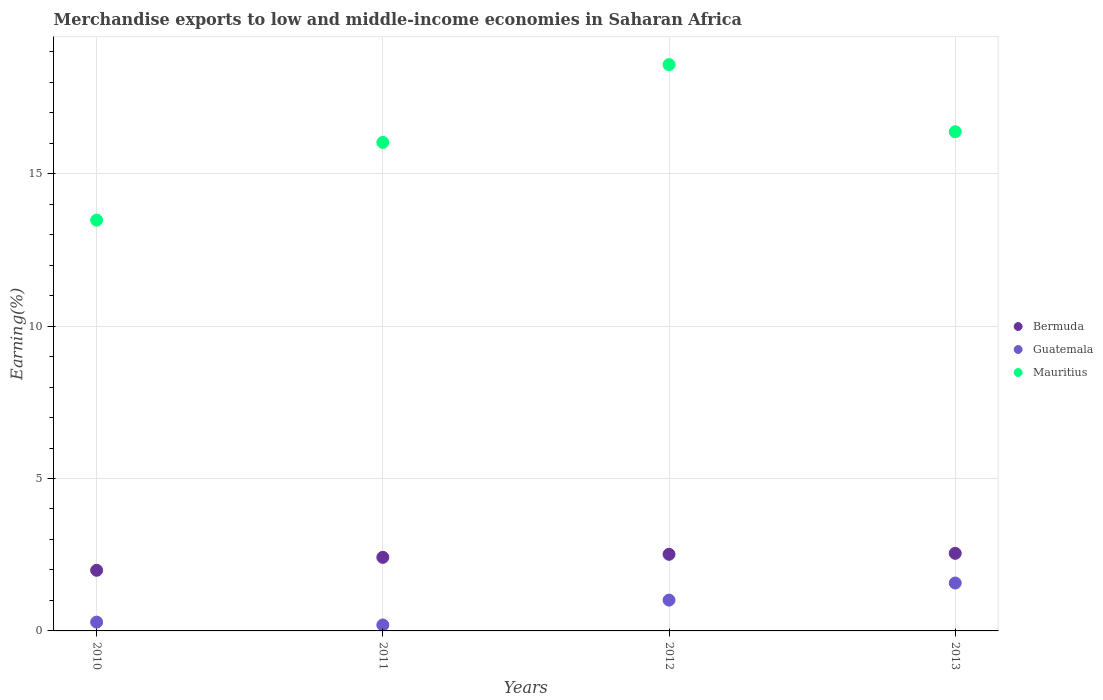How many different coloured dotlines are there?
Provide a short and direct response. 3. What is the percentage of amount earned from merchandise exports in Mauritius in 2010?
Your answer should be very brief. 13.48. Across all years, what is the maximum percentage of amount earned from merchandise exports in Guatemala?
Give a very brief answer. 1.57. Across all years, what is the minimum percentage of amount earned from merchandise exports in Bermuda?
Offer a terse response. 1.99. In which year was the percentage of amount earned from merchandise exports in Guatemala maximum?
Your answer should be very brief. 2013. What is the total percentage of amount earned from merchandise exports in Bermuda in the graph?
Offer a very short reply. 9.46. What is the difference between the percentage of amount earned from merchandise exports in Bermuda in 2011 and that in 2013?
Offer a terse response. -0.13. What is the difference between the percentage of amount earned from merchandise exports in Guatemala in 2011 and the percentage of amount earned from merchandise exports in Bermuda in 2010?
Provide a short and direct response. -1.79. What is the average percentage of amount earned from merchandise exports in Mauritius per year?
Ensure brevity in your answer.  16.11. In the year 2012, what is the difference between the percentage of amount earned from merchandise exports in Bermuda and percentage of amount earned from merchandise exports in Guatemala?
Give a very brief answer. 1.5. In how many years, is the percentage of amount earned from merchandise exports in Mauritius greater than 14 %?
Ensure brevity in your answer.  3. What is the ratio of the percentage of amount earned from merchandise exports in Guatemala in 2011 to that in 2013?
Your answer should be compact. 0.12. Is the percentage of amount earned from merchandise exports in Bermuda in 2010 less than that in 2011?
Your answer should be compact. Yes. Is the difference between the percentage of amount earned from merchandise exports in Bermuda in 2011 and 2012 greater than the difference between the percentage of amount earned from merchandise exports in Guatemala in 2011 and 2012?
Keep it short and to the point. Yes. What is the difference between the highest and the second highest percentage of amount earned from merchandise exports in Mauritius?
Provide a succinct answer. 2.2. What is the difference between the highest and the lowest percentage of amount earned from merchandise exports in Guatemala?
Your answer should be compact. 1.38. In how many years, is the percentage of amount earned from merchandise exports in Bermuda greater than the average percentage of amount earned from merchandise exports in Bermuda taken over all years?
Keep it short and to the point. 3. Is it the case that in every year, the sum of the percentage of amount earned from merchandise exports in Guatemala and percentage of amount earned from merchandise exports in Mauritius  is greater than the percentage of amount earned from merchandise exports in Bermuda?
Offer a very short reply. Yes. Is the percentage of amount earned from merchandise exports in Guatemala strictly greater than the percentage of amount earned from merchandise exports in Mauritius over the years?
Keep it short and to the point. No. Is the percentage of amount earned from merchandise exports in Bermuda strictly less than the percentage of amount earned from merchandise exports in Mauritius over the years?
Your answer should be compact. Yes. How many dotlines are there?
Make the answer very short. 3. What is the difference between two consecutive major ticks on the Y-axis?
Your answer should be compact. 5. Are the values on the major ticks of Y-axis written in scientific E-notation?
Your answer should be compact. No. Does the graph contain any zero values?
Keep it short and to the point. No. Where does the legend appear in the graph?
Give a very brief answer. Center right. How many legend labels are there?
Make the answer very short. 3. How are the legend labels stacked?
Provide a succinct answer. Vertical. What is the title of the graph?
Make the answer very short. Merchandise exports to low and middle-income economies in Saharan Africa. What is the label or title of the Y-axis?
Provide a succinct answer. Earning(%). What is the Earning(%) in Bermuda in 2010?
Your answer should be very brief. 1.99. What is the Earning(%) of Guatemala in 2010?
Make the answer very short. 0.29. What is the Earning(%) in Mauritius in 2010?
Give a very brief answer. 13.48. What is the Earning(%) of Bermuda in 2011?
Provide a short and direct response. 2.41. What is the Earning(%) of Guatemala in 2011?
Provide a succinct answer. 0.2. What is the Earning(%) in Mauritius in 2011?
Your answer should be compact. 16.03. What is the Earning(%) in Bermuda in 2012?
Your answer should be compact. 2.51. What is the Earning(%) in Guatemala in 2012?
Offer a very short reply. 1.01. What is the Earning(%) of Mauritius in 2012?
Give a very brief answer. 18.58. What is the Earning(%) in Bermuda in 2013?
Keep it short and to the point. 2.55. What is the Earning(%) of Guatemala in 2013?
Ensure brevity in your answer.  1.57. What is the Earning(%) in Mauritius in 2013?
Ensure brevity in your answer.  16.38. Across all years, what is the maximum Earning(%) of Bermuda?
Provide a succinct answer. 2.55. Across all years, what is the maximum Earning(%) in Guatemala?
Offer a very short reply. 1.57. Across all years, what is the maximum Earning(%) in Mauritius?
Offer a terse response. 18.58. Across all years, what is the minimum Earning(%) in Bermuda?
Provide a succinct answer. 1.99. Across all years, what is the minimum Earning(%) of Guatemala?
Offer a very short reply. 0.2. Across all years, what is the minimum Earning(%) in Mauritius?
Your answer should be very brief. 13.48. What is the total Earning(%) of Bermuda in the graph?
Keep it short and to the point. 9.46. What is the total Earning(%) of Guatemala in the graph?
Your response must be concise. 3.07. What is the total Earning(%) of Mauritius in the graph?
Make the answer very short. 64.46. What is the difference between the Earning(%) in Bermuda in 2010 and that in 2011?
Make the answer very short. -0.43. What is the difference between the Earning(%) of Guatemala in 2010 and that in 2011?
Give a very brief answer. 0.09. What is the difference between the Earning(%) in Mauritius in 2010 and that in 2011?
Make the answer very short. -2.55. What is the difference between the Earning(%) in Bermuda in 2010 and that in 2012?
Offer a very short reply. -0.52. What is the difference between the Earning(%) of Guatemala in 2010 and that in 2012?
Keep it short and to the point. -0.72. What is the difference between the Earning(%) of Mauritius in 2010 and that in 2012?
Your response must be concise. -5.1. What is the difference between the Earning(%) of Bermuda in 2010 and that in 2013?
Your answer should be compact. -0.56. What is the difference between the Earning(%) of Guatemala in 2010 and that in 2013?
Provide a succinct answer. -1.28. What is the difference between the Earning(%) of Mauritius in 2010 and that in 2013?
Ensure brevity in your answer.  -2.9. What is the difference between the Earning(%) of Bermuda in 2011 and that in 2012?
Offer a terse response. -0.1. What is the difference between the Earning(%) in Guatemala in 2011 and that in 2012?
Make the answer very short. -0.82. What is the difference between the Earning(%) of Mauritius in 2011 and that in 2012?
Your answer should be very brief. -2.55. What is the difference between the Earning(%) in Bermuda in 2011 and that in 2013?
Offer a terse response. -0.13. What is the difference between the Earning(%) of Guatemala in 2011 and that in 2013?
Give a very brief answer. -1.38. What is the difference between the Earning(%) of Mauritius in 2011 and that in 2013?
Keep it short and to the point. -0.35. What is the difference between the Earning(%) of Bermuda in 2012 and that in 2013?
Your response must be concise. -0.03. What is the difference between the Earning(%) of Guatemala in 2012 and that in 2013?
Give a very brief answer. -0.56. What is the difference between the Earning(%) in Mauritius in 2012 and that in 2013?
Provide a succinct answer. 2.2. What is the difference between the Earning(%) in Bermuda in 2010 and the Earning(%) in Guatemala in 2011?
Keep it short and to the point. 1.79. What is the difference between the Earning(%) in Bermuda in 2010 and the Earning(%) in Mauritius in 2011?
Your answer should be compact. -14.04. What is the difference between the Earning(%) of Guatemala in 2010 and the Earning(%) of Mauritius in 2011?
Offer a very short reply. -15.74. What is the difference between the Earning(%) in Bermuda in 2010 and the Earning(%) in Guatemala in 2012?
Give a very brief answer. 0.98. What is the difference between the Earning(%) in Bermuda in 2010 and the Earning(%) in Mauritius in 2012?
Your answer should be compact. -16.59. What is the difference between the Earning(%) in Guatemala in 2010 and the Earning(%) in Mauritius in 2012?
Provide a short and direct response. -18.29. What is the difference between the Earning(%) in Bermuda in 2010 and the Earning(%) in Guatemala in 2013?
Offer a terse response. 0.42. What is the difference between the Earning(%) in Bermuda in 2010 and the Earning(%) in Mauritius in 2013?
Give a very brief answer. -14.39. What is the difference between the Earning(%) of Guatemala in 2010 and the Earning(%) of Mauritius in 2013?
Provide a short and direct response. -16.09. What is the difference between the Earning(%) in Bermuda in 2011 and the Earning(%) in Guatemala in 2012?
Give a very brief answer. 1.4. What is the difference between the Earning(%) in Bermuda in 2011 and the Earning(%) in Mauritius in 2012?
Your answer should be very brief. -16.16. What is the difference between the Earning(%) in Guatemala in 2011 and the Earning(%) in Mauritius in 2012?
Ensure brevity in your answer.  -18.38. What is the difference between the Earning(%) in Bermuda in 2011 and the Earning(%) in Guatemala in 2013?
Make the answer very short. 0.84. What is the difference between the Earning(%) of Bermuda in 2011 and the Earning(%) of Mauritius in 2013?
Keep it short and to the point. -13.96. What is the difference between the Earning(%) in Guatemala in 2011 and the Earning(%) in Mauritius in 2013?
Offer a very short reply. -16.18. What is the difference between the Earning(%) in Bermuda in 2012 and the Earning(%) in Mauritius in 2013?
Give a very brief answer. -13.86. What is the difference between the Earning(%) of Guatemala in 2012 and the Earning(%) of Mauritius in 2013?
Give a very brief answer. -15.36. What is the average Earning(%) in Bermuda per year?
Provide a short and direct response. 2.37. What is the average Earning(%) of Guatemala per year?
Keep it short and to the point. 0.77. What is the average Earning(%) of Mauritius per year?
Offer a very short reply. 16.11. In the year 2010, what is the difference between the Earning(%) of Bermuda and Earning(%) of Guatemala?
Make the answer very short. 1.7. In the year 2010, what is the difference between the Earning(%) in Bermuda and Earning(%) in Mauritius?
Provide a short and direct response. -11.49. In the year 2010, what is the difference between the Earning(%) of Guatemala and Earning(%) of Mauritius?
Keep it short and to the point. -13.19. In the year 2011, what is the difference between the Earning(%) in Bermuda and Earning(%) in Guatemala?
Your response must be concise. 2.22. In the year 2011, what is the difference between the Earning(%) in Bermuda and Earning(%) in Mauritius?
Your response must be concise. -13.61. In the year 2011, what is the difference between the Earning(%) in Guatemala and Earning(%) in Mauritius?
Ensure brevity in your answer.  -15.83. In the year 2012, what is the difference between the Earning(%) in Bermuda and Earning(%) in Guatemala?
Your answer should be compact. 1.5. In the year 2012, what is the difference between the Earning(%) of Bermuda and Earning(%) of Mauritius?
Provide a short and direct response. -16.06. In the year 2012, what is the difference between the Earning(%) of Guatemala and Earning(%) of Mauritius?
Give a very brief answer. -17.57. In the year 2013, what is the difference between the Earning(%) of Bermuda and Earning(%) of Guatemala?
Offer a terse response. 0.97. In the year 2013, what is the difference between the Earning(%) of Bermuda and Earning(%) of Mauritius?
Your response must be concise. -13.83. In the year 2013, what is the difference between the Earning(%) of Guatemala and Earning(%) of Mauritius?
Offer a very short reply. -14.8. What is the ratio of the Earning(%) of Bermuda in 2010 to that in 2011?
Your answer should be very brief. 0.82. What is the ratio of the Earning(%) of Guatemala in 2010 to that in 2011?
Your answer should be very brief. 1.48. What is the ratio of the Earning(%) of Mauritius in 2010 to that in 2011?
Make the answer very short. 0.84. What is the ratio of the Earning(%) of Bermuda in 2010 to that in 2012?
Offer a very short reply. 0.79. What is the ratio of the Earning(%) in Guatemala in 2010 to that in 2012?
Your answer should be very brief. 0.29. What is the ratio of the Earning(%) in Mauritius in 2010 to that in 2012?
Your answer should be very brief. 0.73. What is the ratio of the Earning(%) of Bermuda in 2010 to that in 2013?
Ensure brevity in your answer.  0.78. What is the ratio of the Earning(%) in Guatemala in 2010 to that in 2013?
Keep it short and to the point. 0.18. What is the ratio of the Earning(%) of Mauritius in 2010 to that in 2013?
Give a very brief answer. 0.82. What is the ratio of the Earning(%) of Bermuda in 2011 to that in 2012?
Provide a short and direct response. 0.96. What is the ratio of the Earning(%) of Guatemala in 2011 to that in 2012?
Your answer should be very brief. 0.19. What is the ratio of the Earning(%) in Mauritius in 2011 to that in 2012?
Make the answer very short. 0.86. What is the ratio of the Earning(%) in Bermuda in 2011 to that in 2013?
Offer a very short reply. 0.95. What is the ratio of the Earning(%) of Guatemala in 2011 to that in 2013?
Make the answer very short. 0.12. What is the ratio of the Earning(%) in Mauritius in 2011 to that in 2013?
Your answer should be compact. 0.98. What is the ratio of the Earning(%) in Bermuda in 2012 to that in 2013?
Give a very brief answer. 0.99. What is the ratio of the Earning(%) of Guatemala in 2012 to that in 2013?
Your answer should be very brief. 0.64. What is the ratio of the Earning(%) of Mauritius in 2012 to that in 2013?
Keep it short and to the point. 1.13. What is the difference between the highest and the second highest Earning(%) in Bermuda?
Your answer should be compact. 0.03. What is the difference between the highest and the second highest Earning(%) of Guatemala?
Offer a terse response. 0.56. What is the difference between the highest and the second highest Earning(%) in Mauritius?
Your response must be concise. 2.2. What is the difference between the highest and the lowest Earning(%) in Bermuda?
Keep it short and to the point. 0.56. What is the difference between the highest and the lowest Earning(%) in Guatemala?
Give a very brief answer. 1.38. What is the difference between the highest and the lowest Earning(%) of Mauritius?
Offer a very short reply. 5.1. 